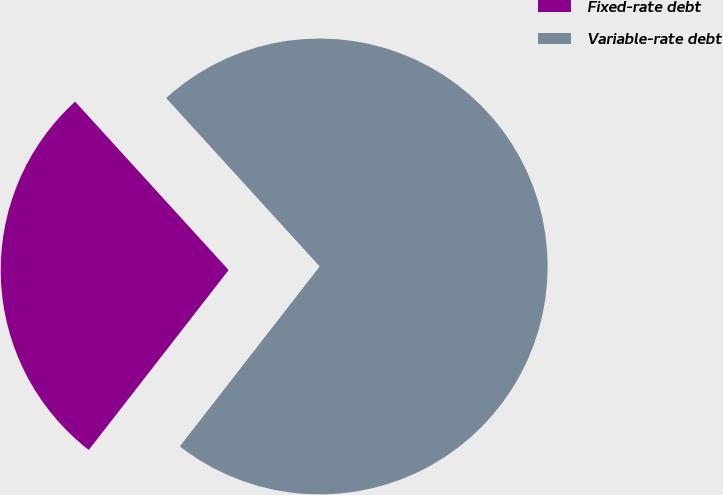<chart> <loc_0><loc_0><loc_500><loc_500><pie_chart><fcel>Fixed-rate debt<fcel>Variable-rate debt<nl><fcel>27.72%<fcel>72.28%<nl></chart> 